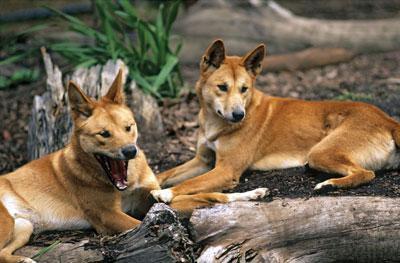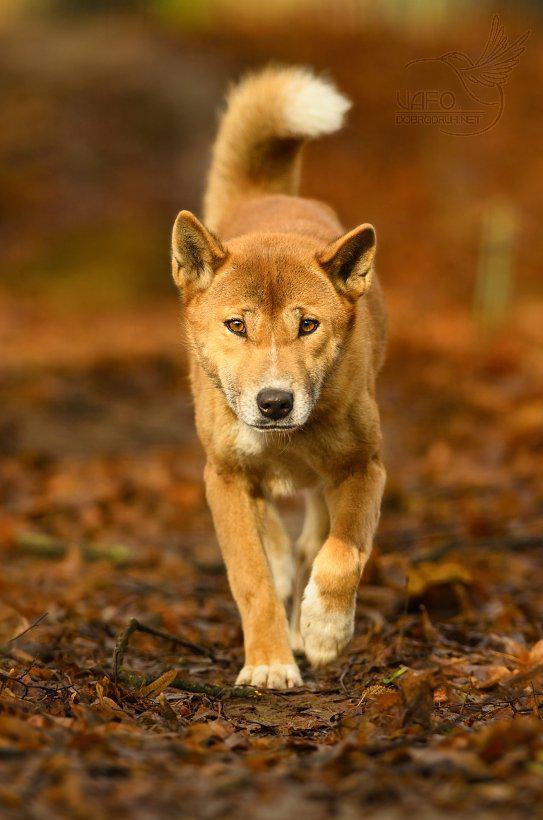The first image is the image on the left, the second image is the image on the right. Considering the images on both sides, is "A total of three canine animals are shown." valid? Answer yes or no. Yes. The first image is the image on the left, the second image is the image on the right. Examine the images to the left and right. Is the description "There are no less than four animals" accurate? Answer yes or no. No. 